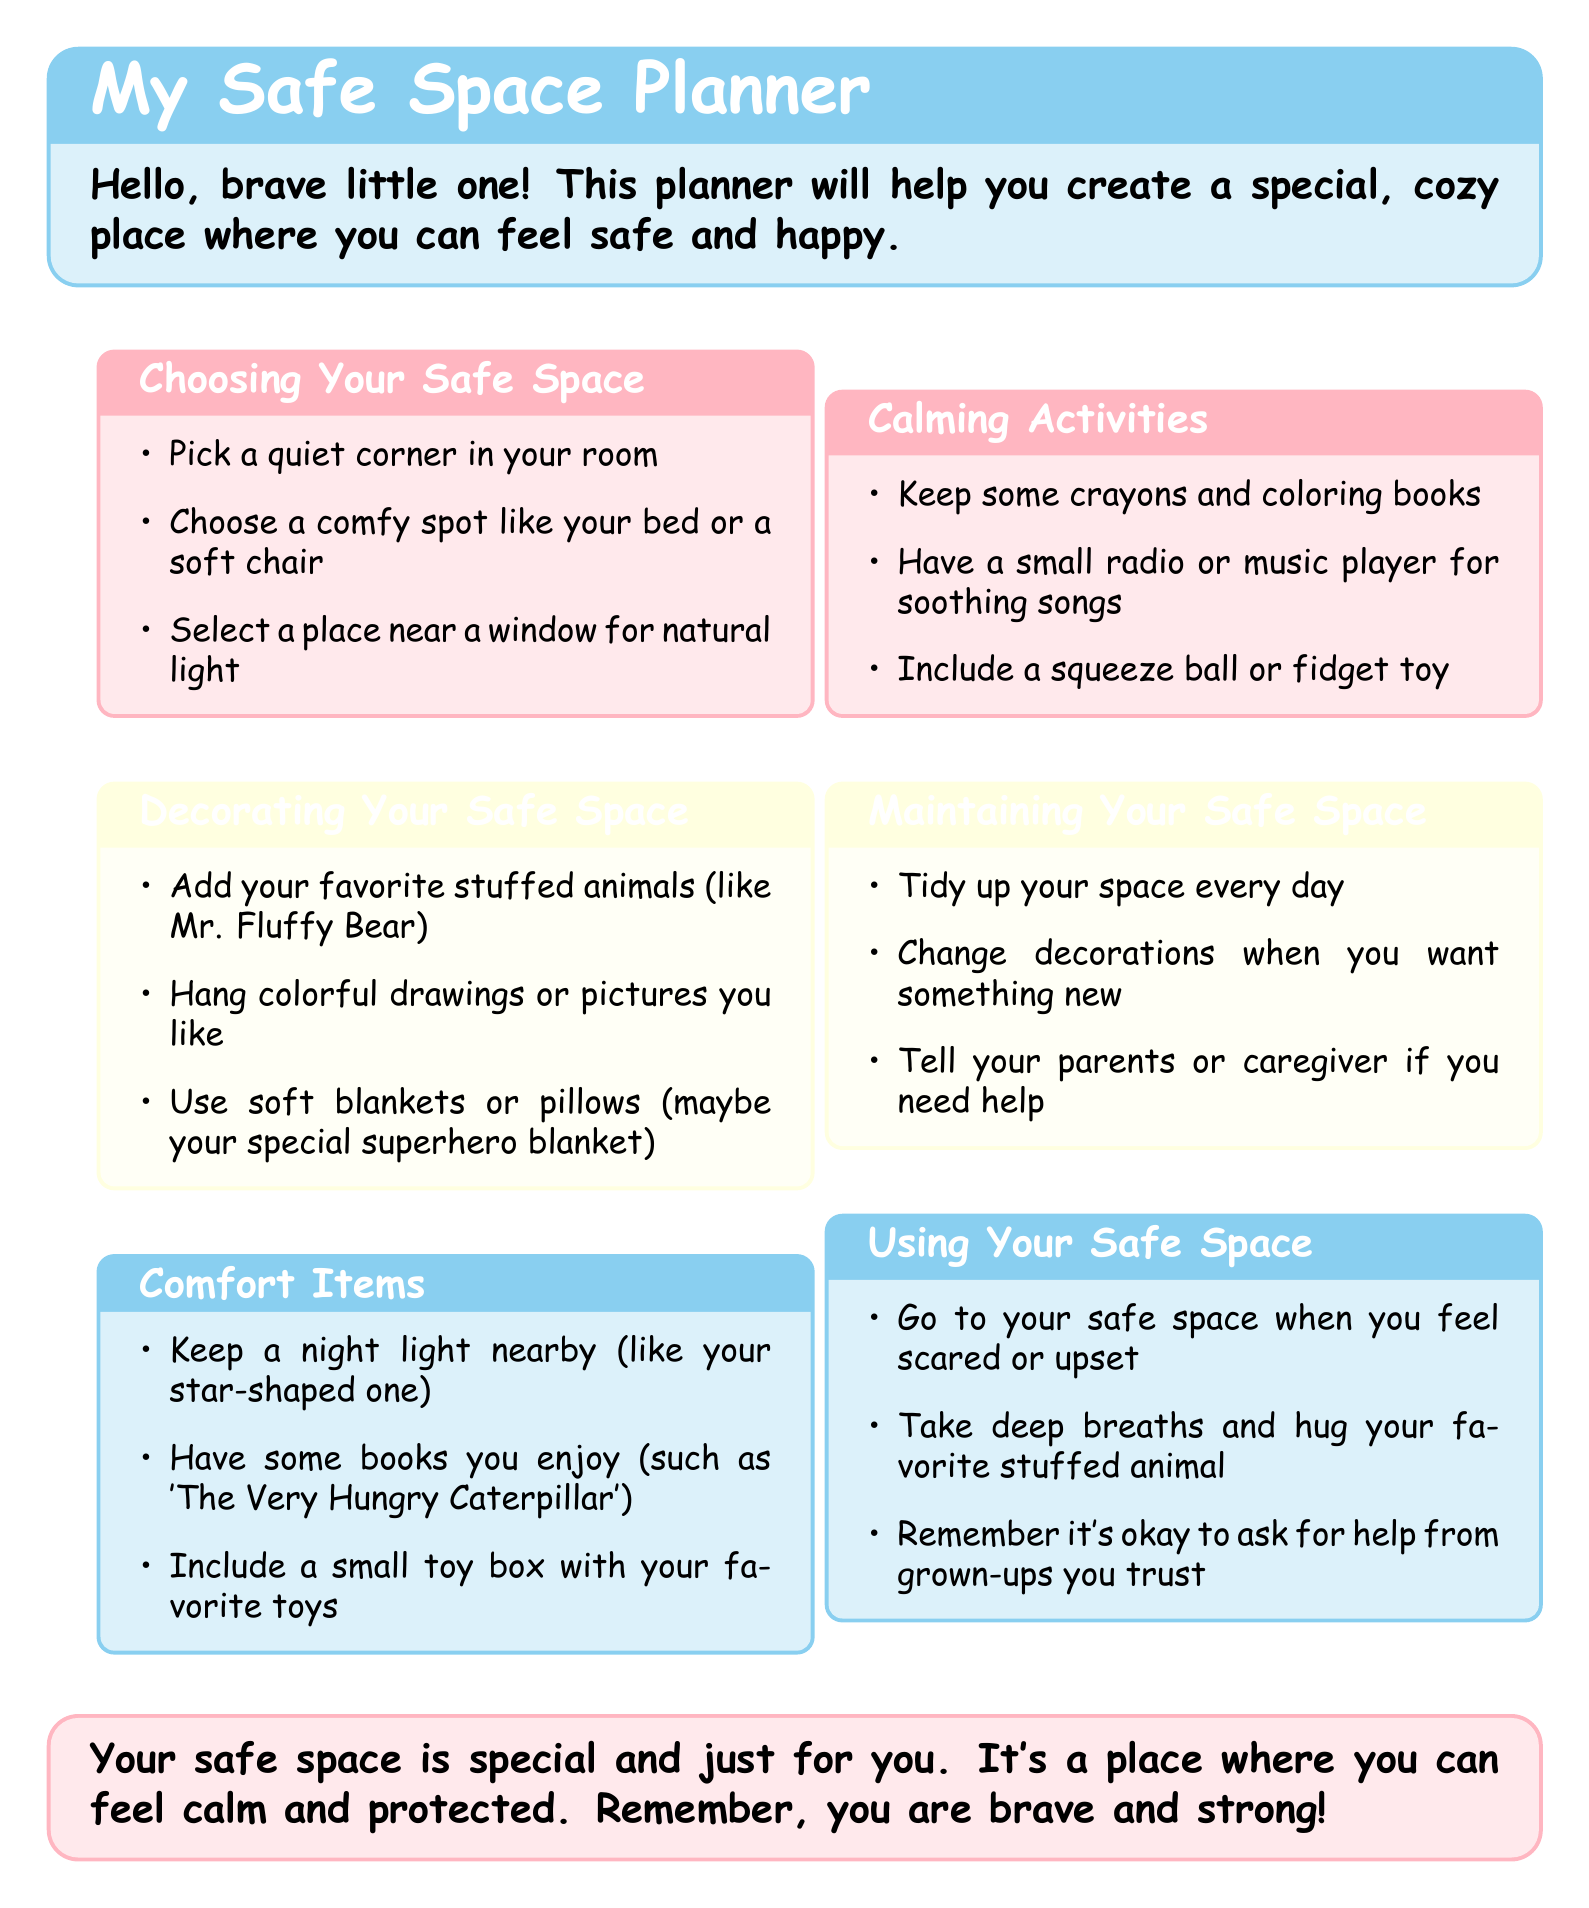What is the title of the planner? The title is prominently displayed at the top of the document.
Answer: My Safe Space Planner What color is used for the 'Comfort Items' section? The document specifies a unique color for each section; this is one of them.
Answer: Baby blue How many items are listed under 'Calming Activities'? The document has a list under this section that can be counted.
Answer: Three What should you keep nearby for comfort? The document mentions a specific item that provides comfort.
Answer: Night light What is one suggested place to choose for your safe space? The document lists options for choosing a space; one of them is easily referenced.
Answer: Quiet corner What can you do if you need help maintaining your space? The document recommends a specific course of action in this situation.
Answer: Tell your parents or caregiver What should you do when you feel scared? The document provides guidance on actions to take in this emotional state.
Answer: Go to your safe space What type of items does the planner encourage to decorate your space? The document lists several things for decoration; this is a general description.
Answer: Favorite stuffed animals How can you maintain your safe space? This question encompasses the actions suggested in the document.
Answer: Tidy up your space every day 